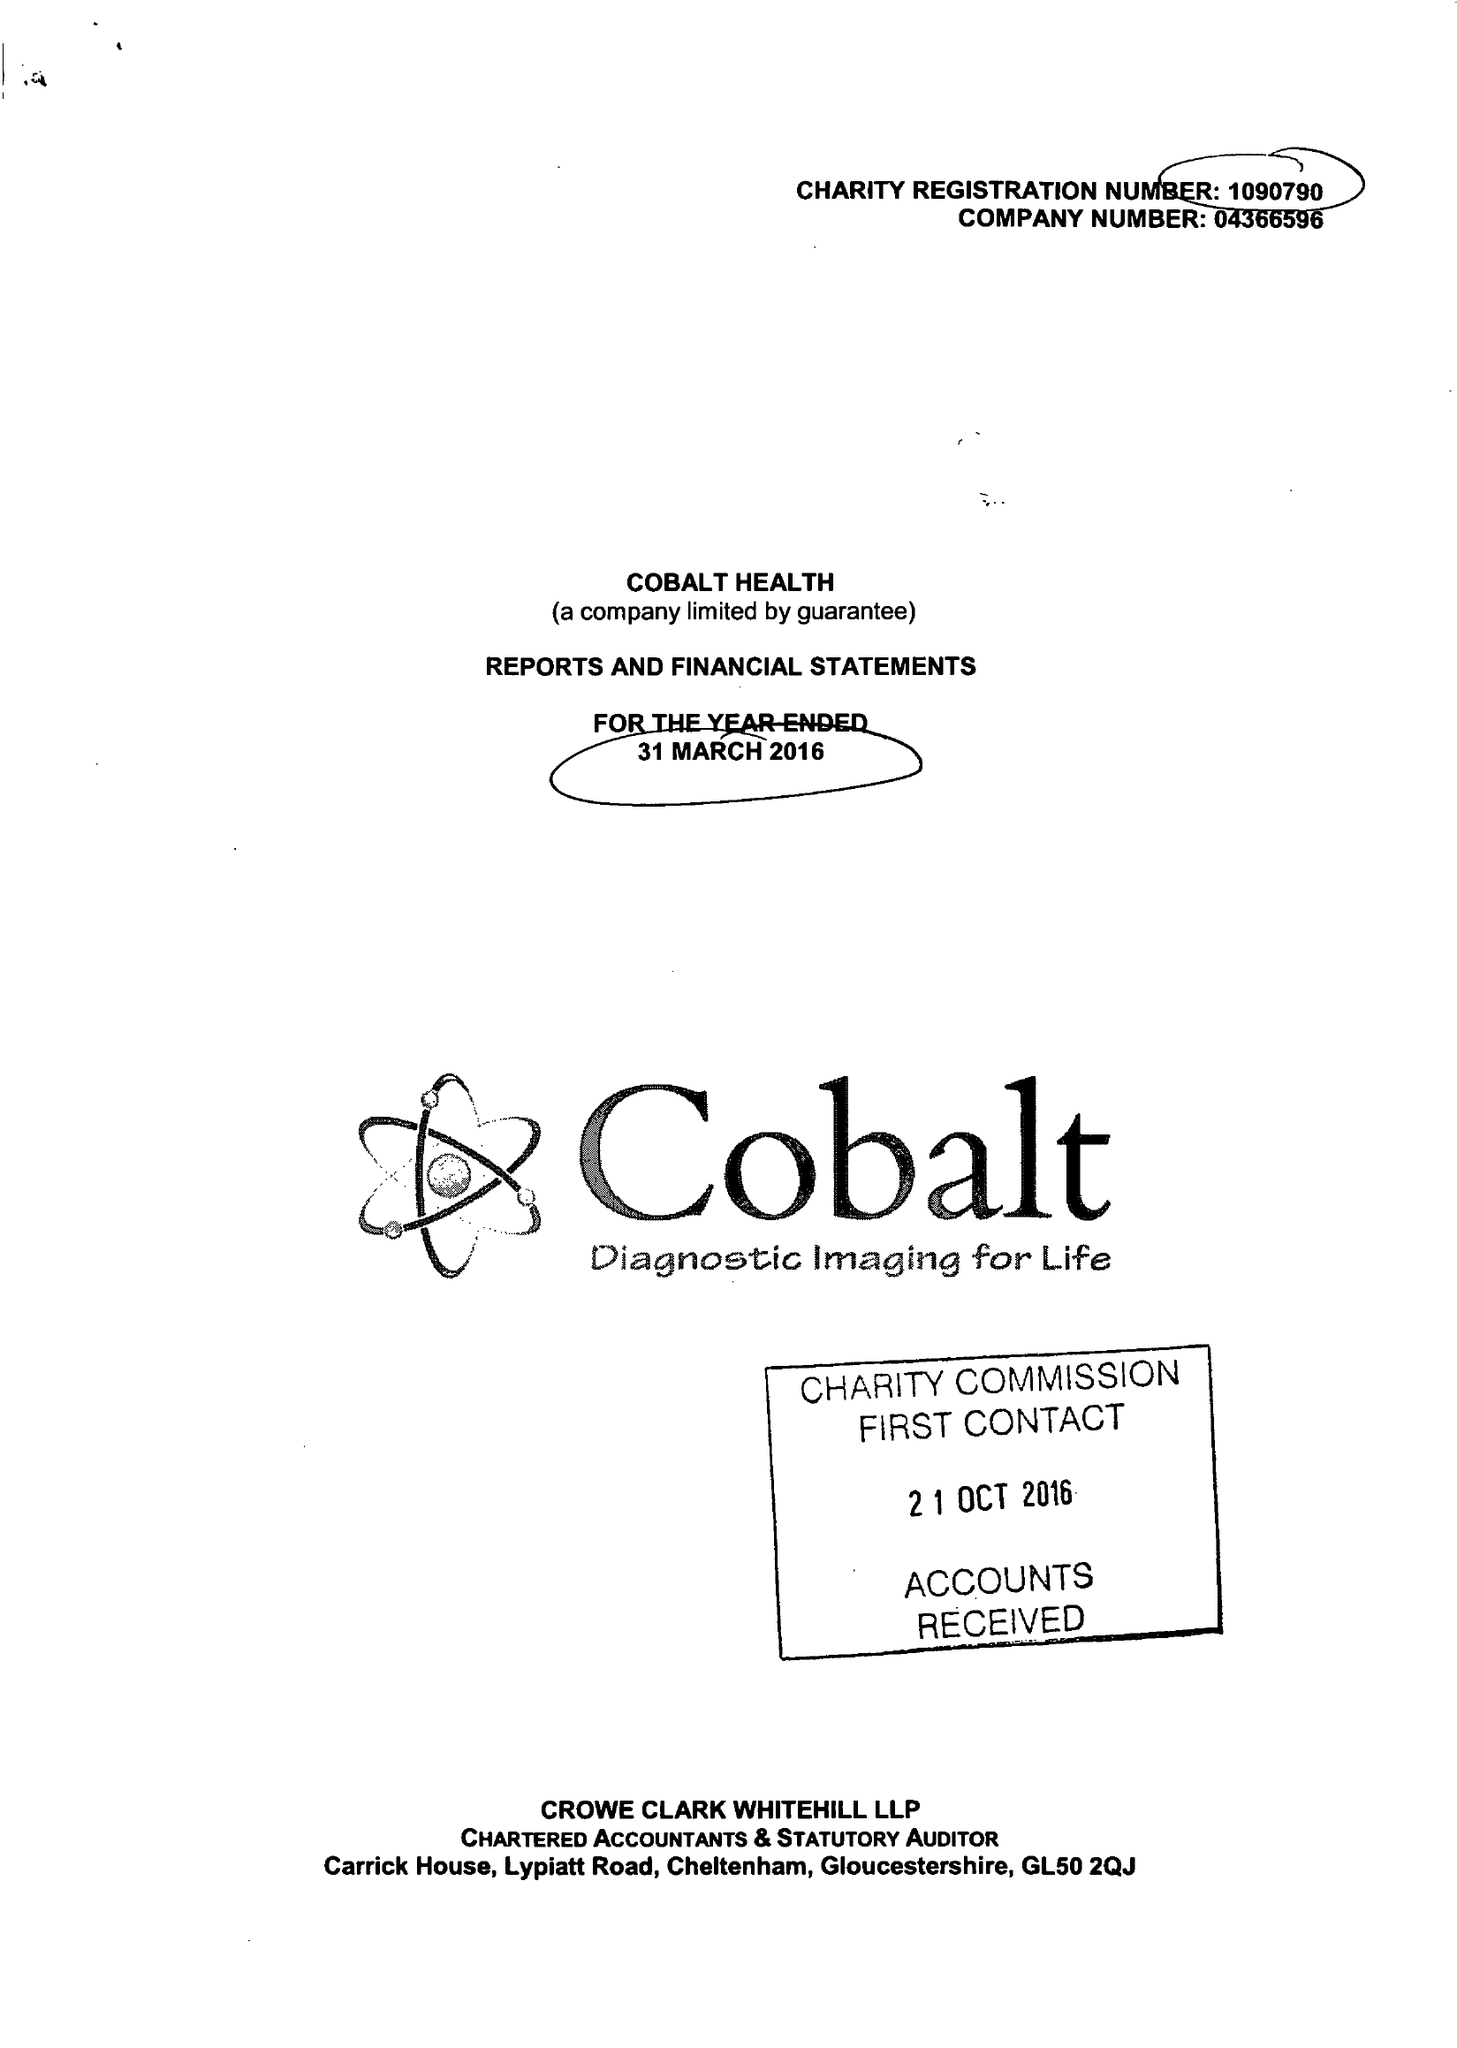What is the value for the income_annually_in_british_pounds?
Answer the question using a single word or phrase. 8770198.00 